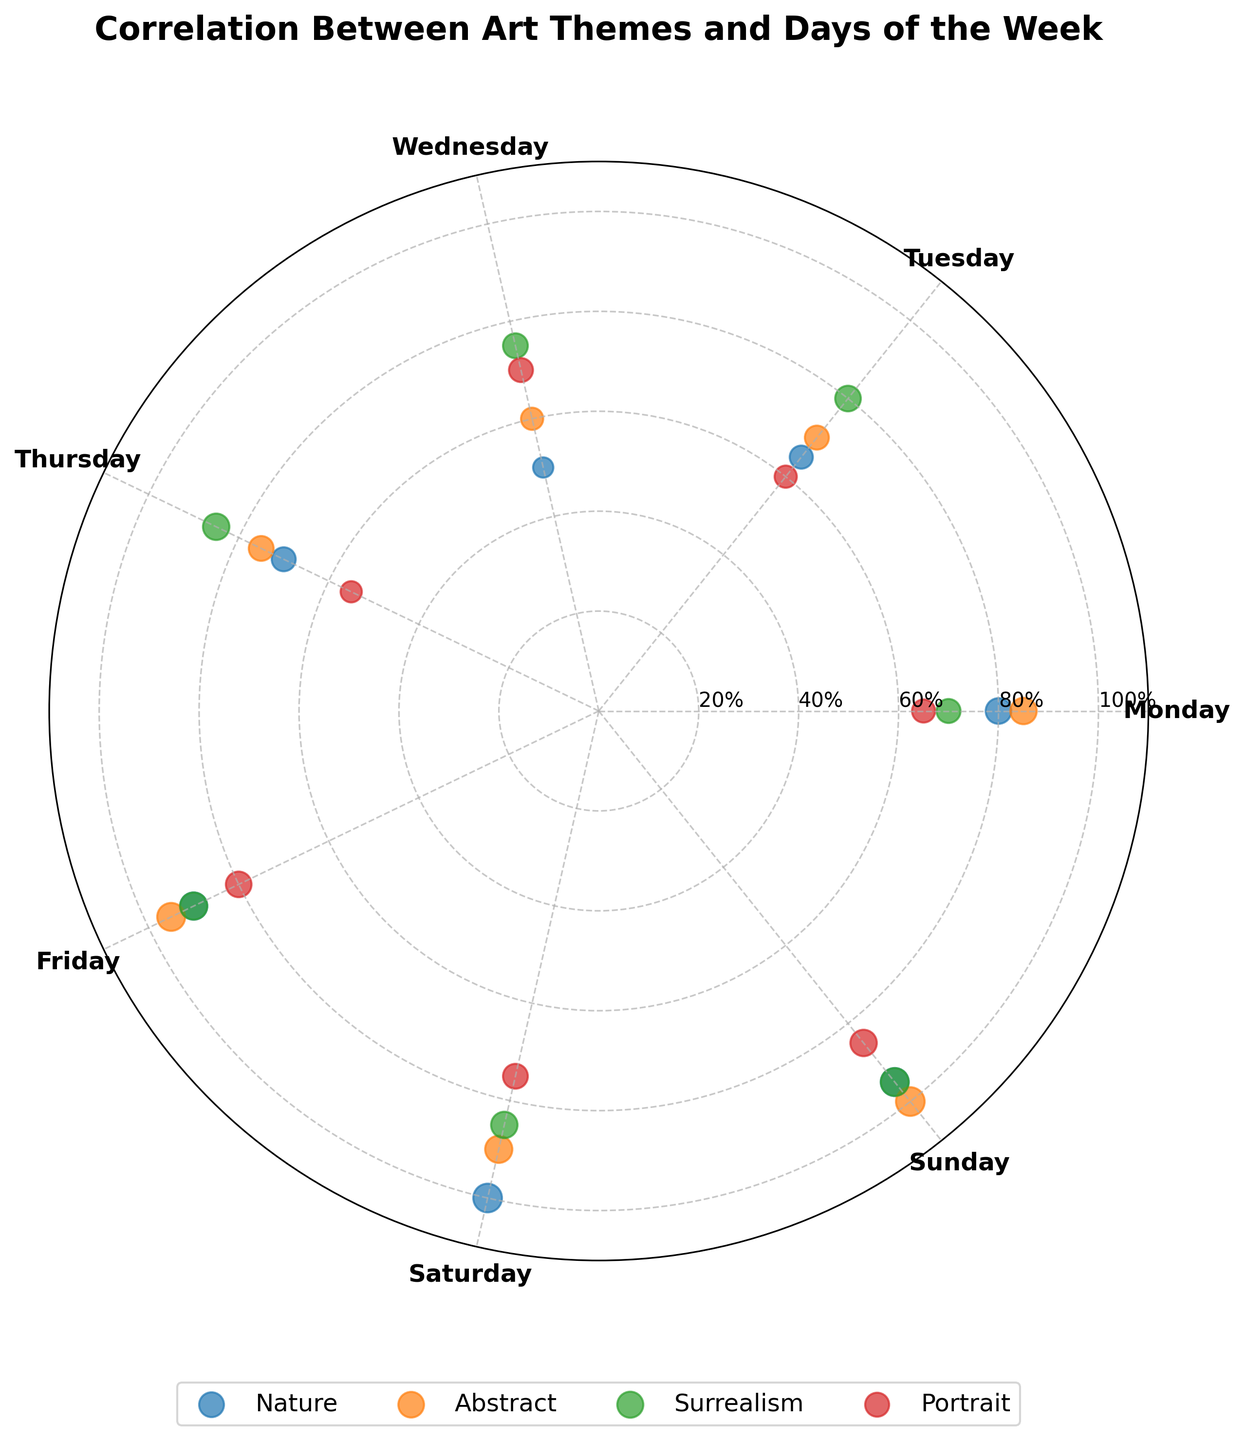How many data points are there for each theme? Since there are 7 days in the week and 4 themes displayed on the plot, each theme will have a data point for every day, leading to 7 data points per theme.
Answer: 7 Which day has the highest popularity for the "Portrait" theme? To find this, observe the points for the "Portrait" theme and identify the day with the highest value. Sunday has the highest popularity of 85 for the "Portrait" theme.
Answer: Sunday Compare the popularity of "Nature" and "Abstract" on Wednesday. Which one is higher and by how much? Look at the points marked for "Nature" and "Abstract" on Wednesday. "Nature" has a popularity of 50 and "Abstract" has 60. The difference is: 60 - 50 = 10. "Abstract" is more popular than "Nature" by 10 on Wednesday.
Answer: Abstract is more popular by 10 What is the average popularity of the "Surrealism" theme over the week? Add the popularity values for "Surrealism" from Monday to Sunday (70 + 80 + 75 + 85 + 90 + 85 + 95 = 580). Then divide by the number of days (7): 580 / 7 = 82.86 (approximately 83).
Answer: Approximately 83 Which theme has the most stable popularity through the week? Stability can be inferred from points being closer together in value. By visually inspecting the chart, "Surrealism" shows the least variation in the popularity values, ranging from 70 to 95 without significant steep changes.
Answer: Surrealism Which theme has the highest peak popularity and on which day? Identify the highest point among all themes and days. For "Nature," the highest is 100 on Saturday. For "Abstract," it's 100 on Sunday. For "Surrealism," it's 95 on Sunday. For "Portrait," it's 85 on Sunday. The highest peak is for "Abstract" and "Nature," both with 100, on Sunday and Saturday respectively.
Answer: Nature on Saturday, Abstract on Sunday On which day do all themes have their highest popularity combined? Sum the popularity for all themes per day and identify the day with the highest total. Saturday's sum is: 100 (Nature) + 90 (Abstract) + 85 (Surrealism) + 75 (Portrait) = 350.
Answer: Saturday 